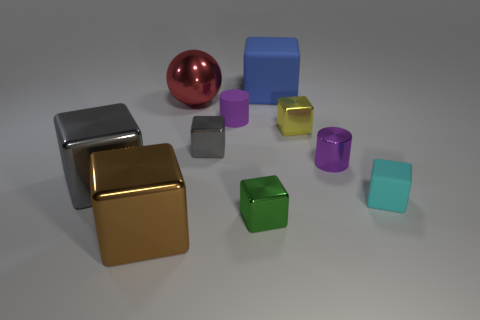What is the size of the green shiny thing that is the same shape as the brown thing?
Provide a succinct answer. Small. The small rubber thing that is the same shape as the brown metal thing is what color?
Keep it short and to the point. Cyan. What number of small matte cylinders have the same color as the small metallic cylinder?
Your response must be concise. 1. What is the red ball made of?
Offer a terse response. Metal. Do the purple cylinder that is right of the green block and the tiny cube to the left of the tiny purple matte thing have the same material?
Provide a short and direct response. Yes. Is there a gray metal object that has the same shape as the blue thing?
Your answer should be very brief. Yes. How many things are either blocks that are left of the big red metallic sphere or big metallic spheres?
Provide a short and direct response. 3. Are there more large blocks behind the big brown thing than large blue rubber cubes on the right side of the blue rubber block?
Offer a very short reply. Yes. What number of rubber things are small brown blocks or large gray objects?
Provide a succinct answer. 0. There is a tiny object that is the same color as the matte cylinder; what is it made of?
Provide a succinct answer. Metal. 